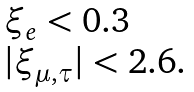Convert formula to latex. <formula><loc_0><loc_0><loc_500><loc_500>\begin{array} { l } \xi _ { e } < 0 . 3 \\ | \xi _ { \mu , \tau } | < 2 . 6 . \end{array}</formula> 